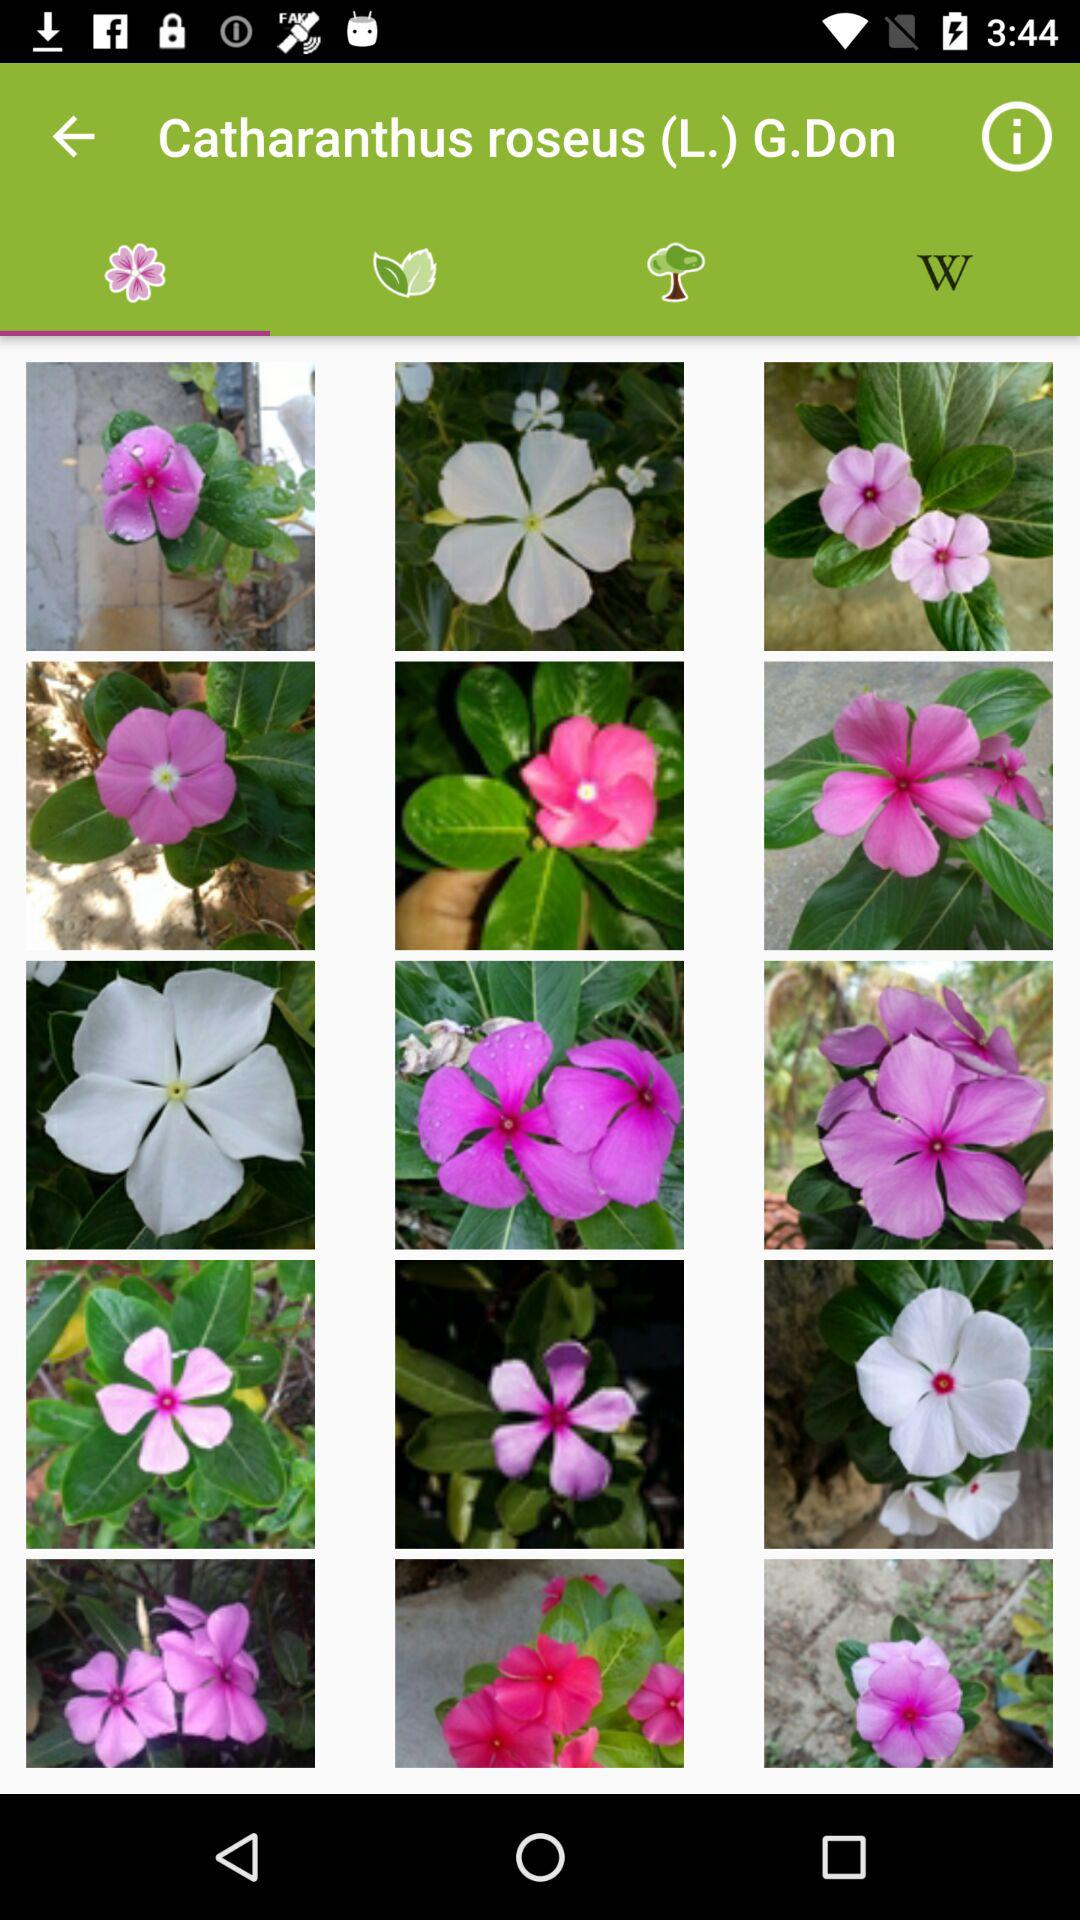How many items have a yellow center?
Answer the question using a single word or phrase. 3 